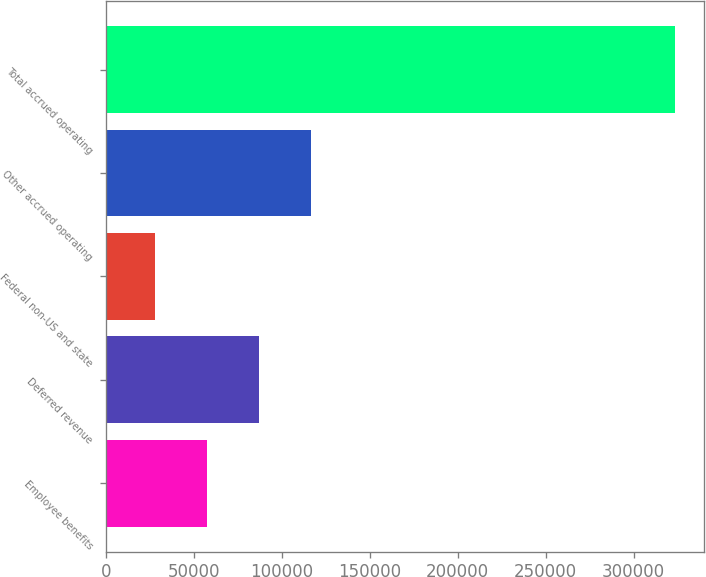Convert chart. <chart><loc_0><loc_0><loc_500><loc_500><bar_chart><fcel>Employee benefits<fcel>Deferred revenue<fcel>Federal non-US and state<fcel>Other accrued operating<fcel>Total accrued operating<nl><fcel>57658<fcel>87231<fcel>28085<fcel>116804<fcel>323815<nl></chart> 